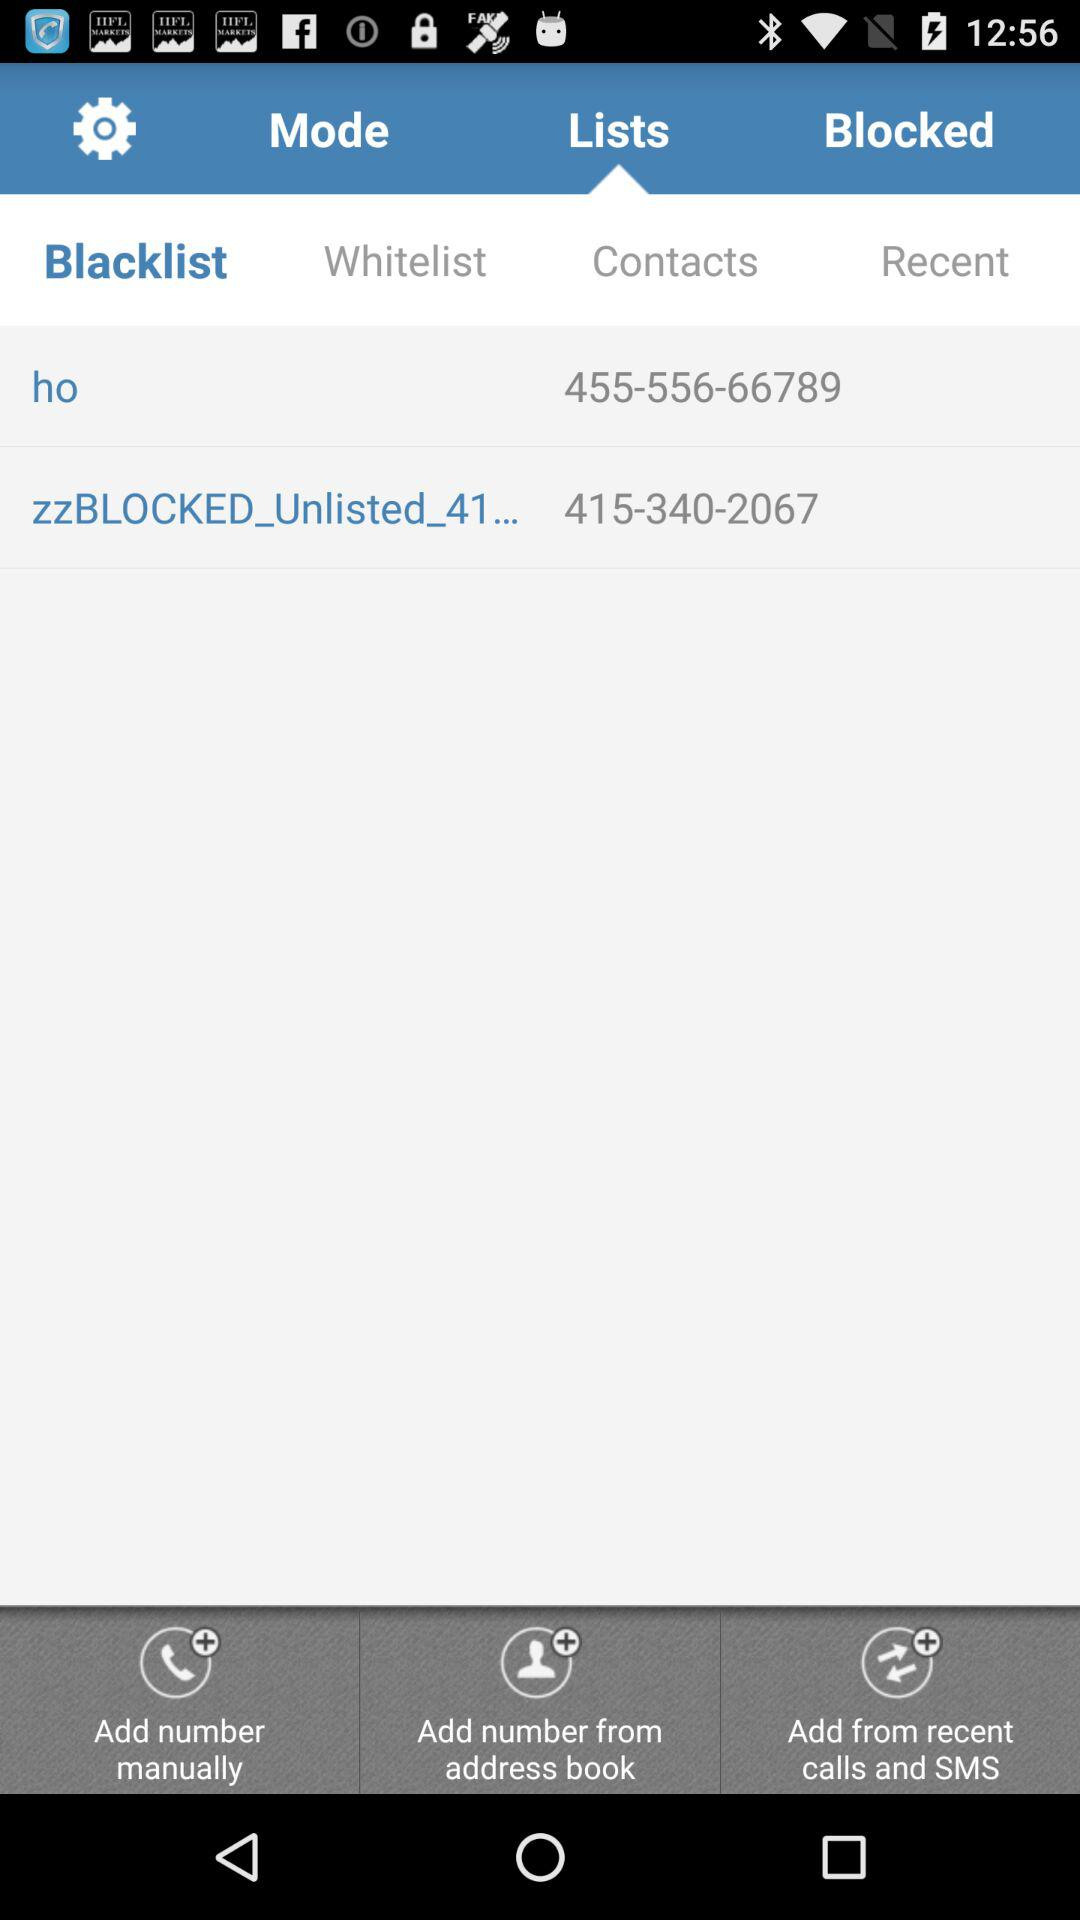What are the numbers in "Blacklist"? The numbers in "Blacklist" are 455-556-66789 and 415-340-2067. 